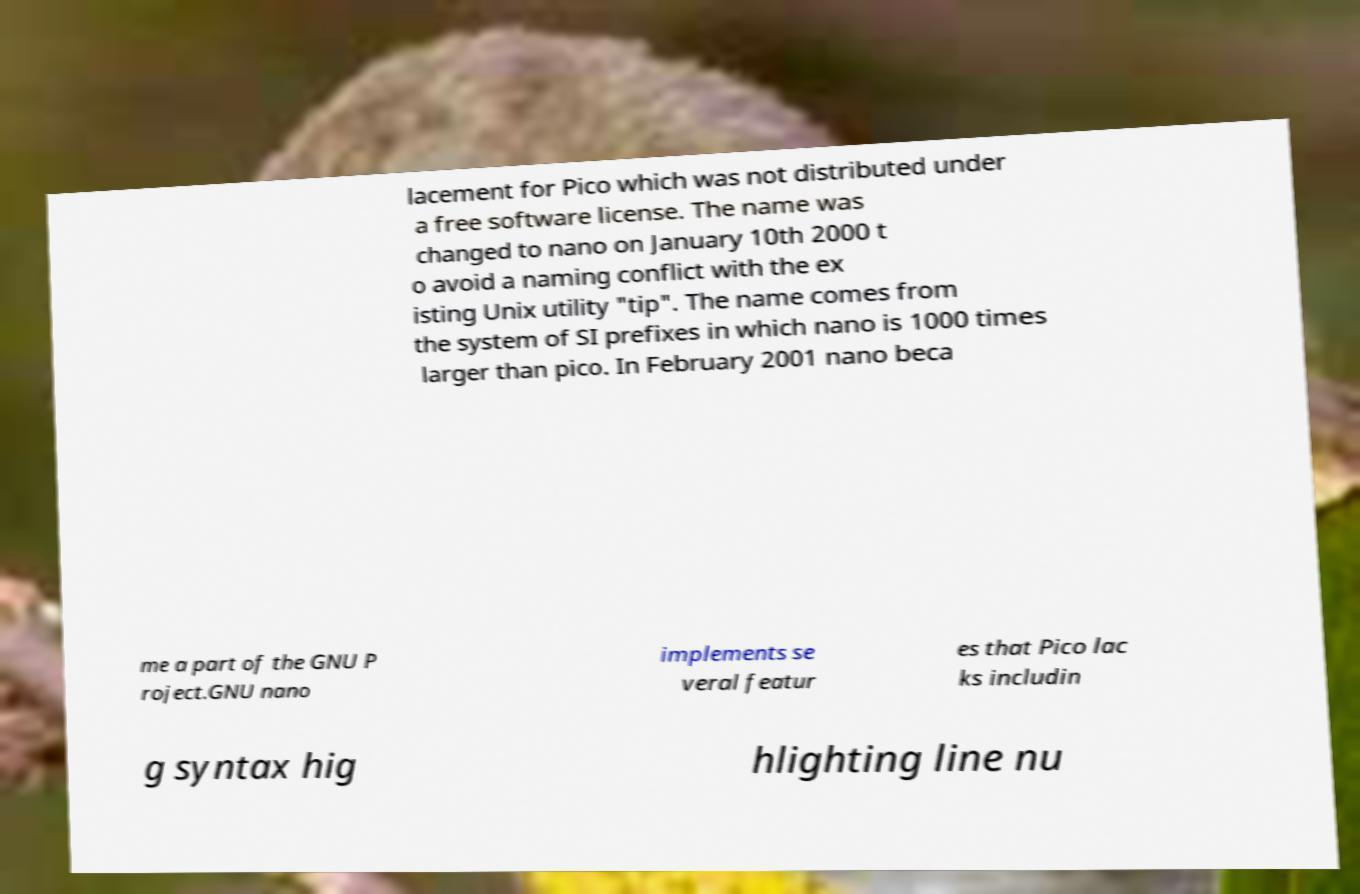What messages or text are displayed in this image? I need them in a readable, typed format. lacement for Pico which was not distributed under a free software license. The name was changed to nano on January 10th 2000 t o avoid a naming conflict with the ex isting Unix utility "tip". The name comes from the system of SI prefixes in which nano is 1000 times larger than pico. In February 2001 nano beca me a part of the GNU P roject.GNU nano implements se veral featur es that Pico lac ks includin g syntax hig hlighting line nu 